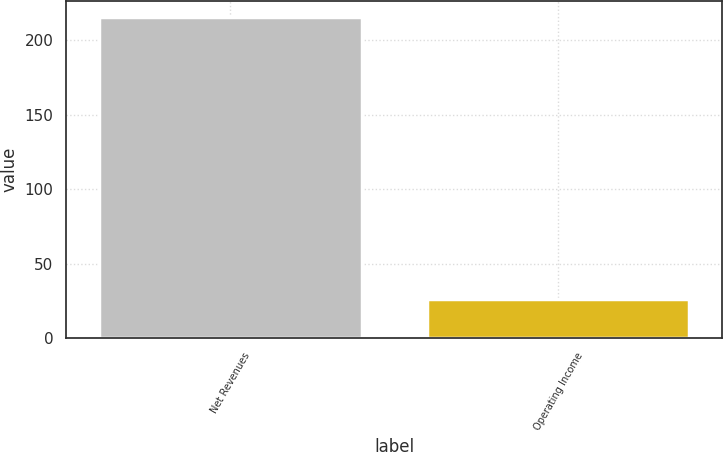<chart> <loc_0><loc_0><loc_500><loc_500><bar_chart><fcel>Net Revenues<fcel>Operating Income<nl><fcel>216<fcel>26<nl></chart> 